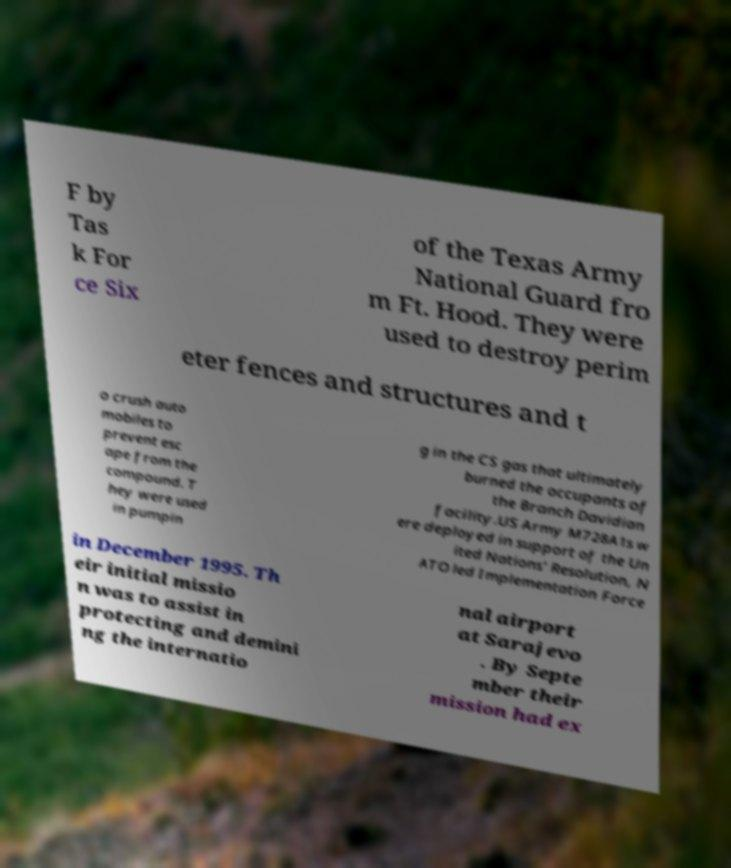Can you read and provide the text displayed in the image?This photo seems to have some interesting text. Can you extract and type it out for me? F by Tas k For ce Six of the Texas Army National Guard fro m Ft. Hood. They were used to destroy perim eter fences and structures and t o crush auto mobiles to prevent esc ape from the compound. T hey were used in pumpin g in the CS gas that ultimately burned the occupants of the Branch Davidian facility.US Army M728A1s w ere deployed in support of the Un ited Nations' Resolution, N ATO led Implementation Force in December 1995. Th eir initial missio n was to assist in protecting and demini ng the internatio nal airport at Sarajevo . By Septe mber their mission had ex 